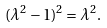Convert formula to latex. <formula><loc_0><loc_0><loc_500><loc_500>( \lambda ^ { 2 } - 1 ) ^ { 2 } = \lambda ^ { 2 } .</formula> 